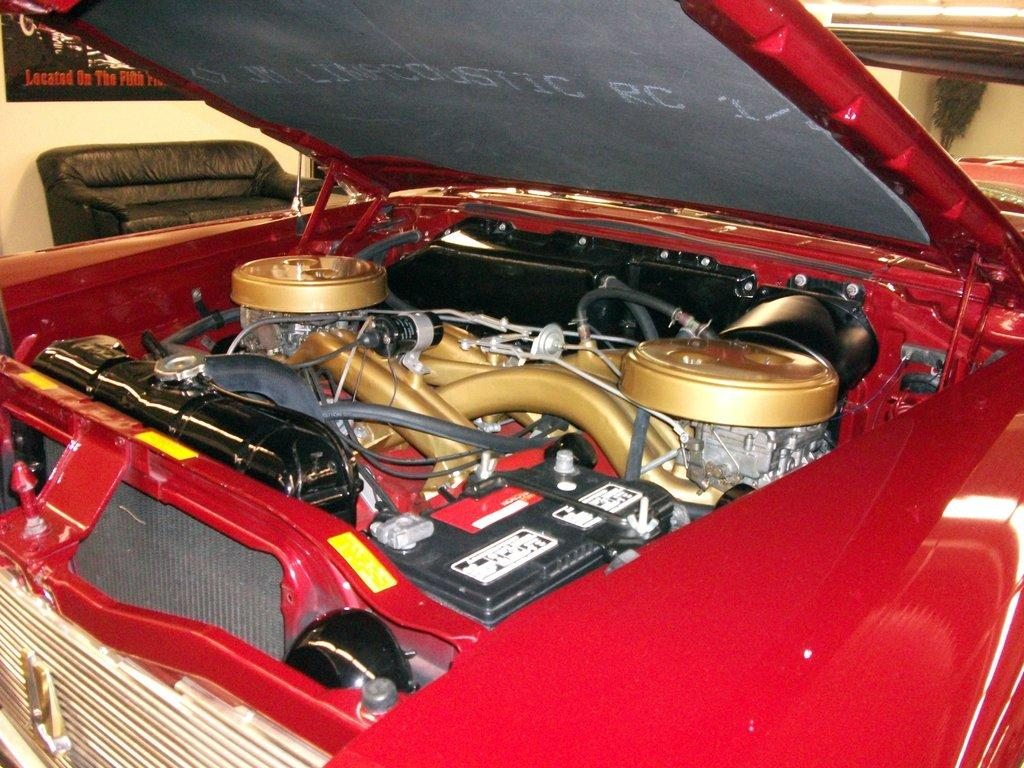What is the main subject of the image? There is a car in the image. What can be seen inside the car? There are objects inside the car. What type of furniture is present in the image? There is a sofa in the image. What is on the wall in the image? There is a poster on a wall in the image. How many pets are visible in the image? There are no pets visible in the image. 